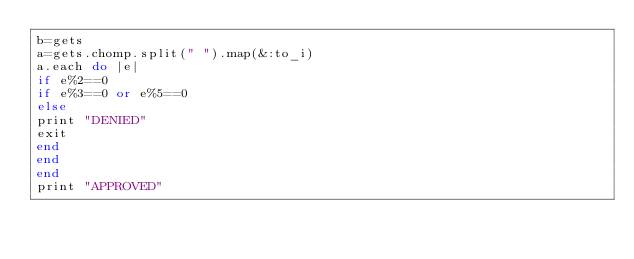<code> <loc_0><loc_0><loc_500><loc_500><_Ruby_>b=gets
a=gets.chomp.split(" ").map(&:to_i)
a.each do |e|
if e%2==0 
if e%3==0 or e%5==0
else
print "DENIED"
exit
end
end 
end
print "APPROVED" </code> 